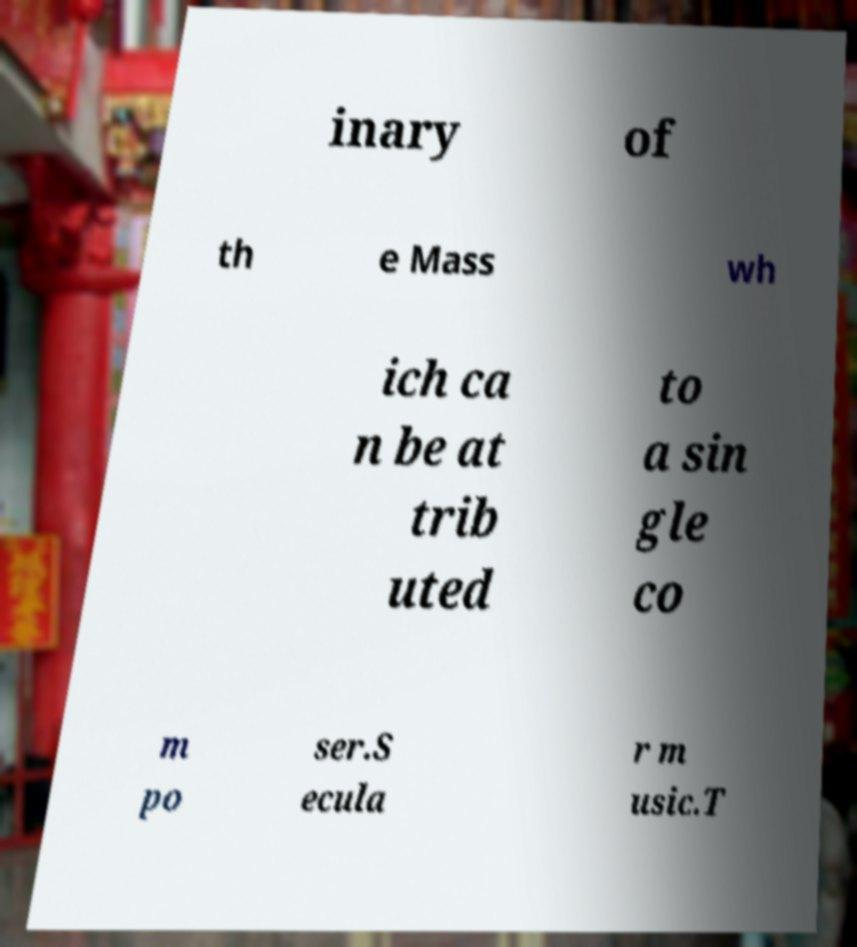Could you extract and type out the text from this image? inary of th e Mass wh ich ca n be at trib uted to a sin gle co m po ser.S ecula r m usic.T 